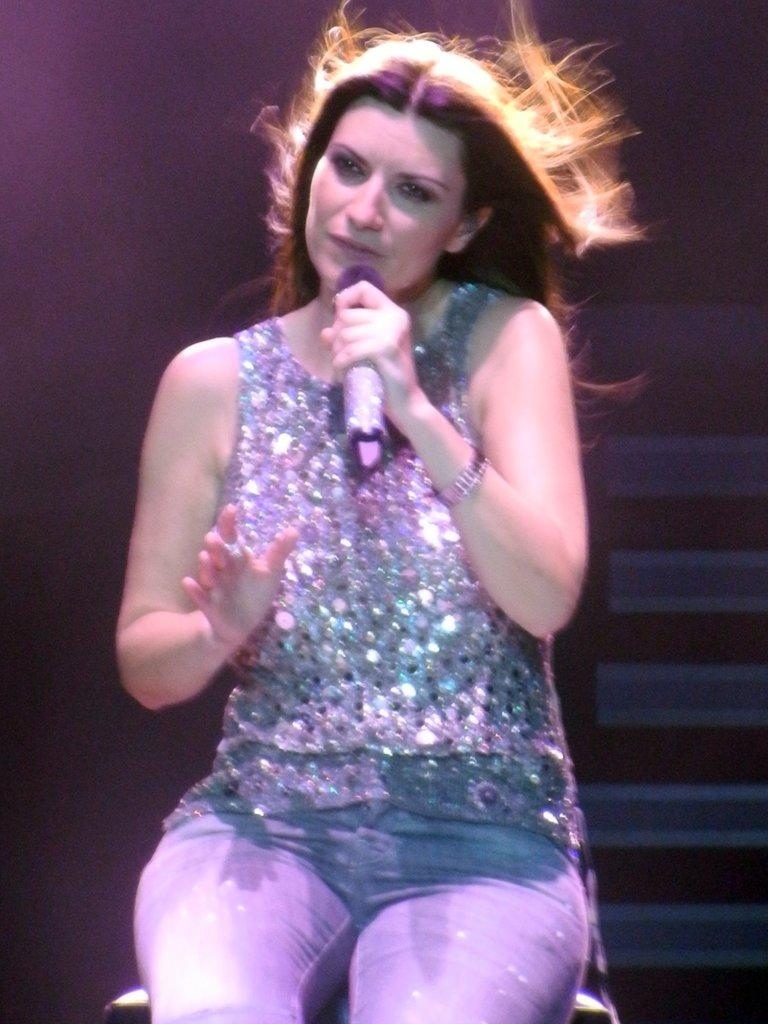Who is the main subject in the image? There is a woman in the image. What is the woman doing in the image? The woman is sitting in the image. What object is the woman holding in the image? The woman is holding a microphone in the image. What type of garden can be seen in the background of the image? There is no garden visible in the image; it only features a woman sitting and holding a microphone. 